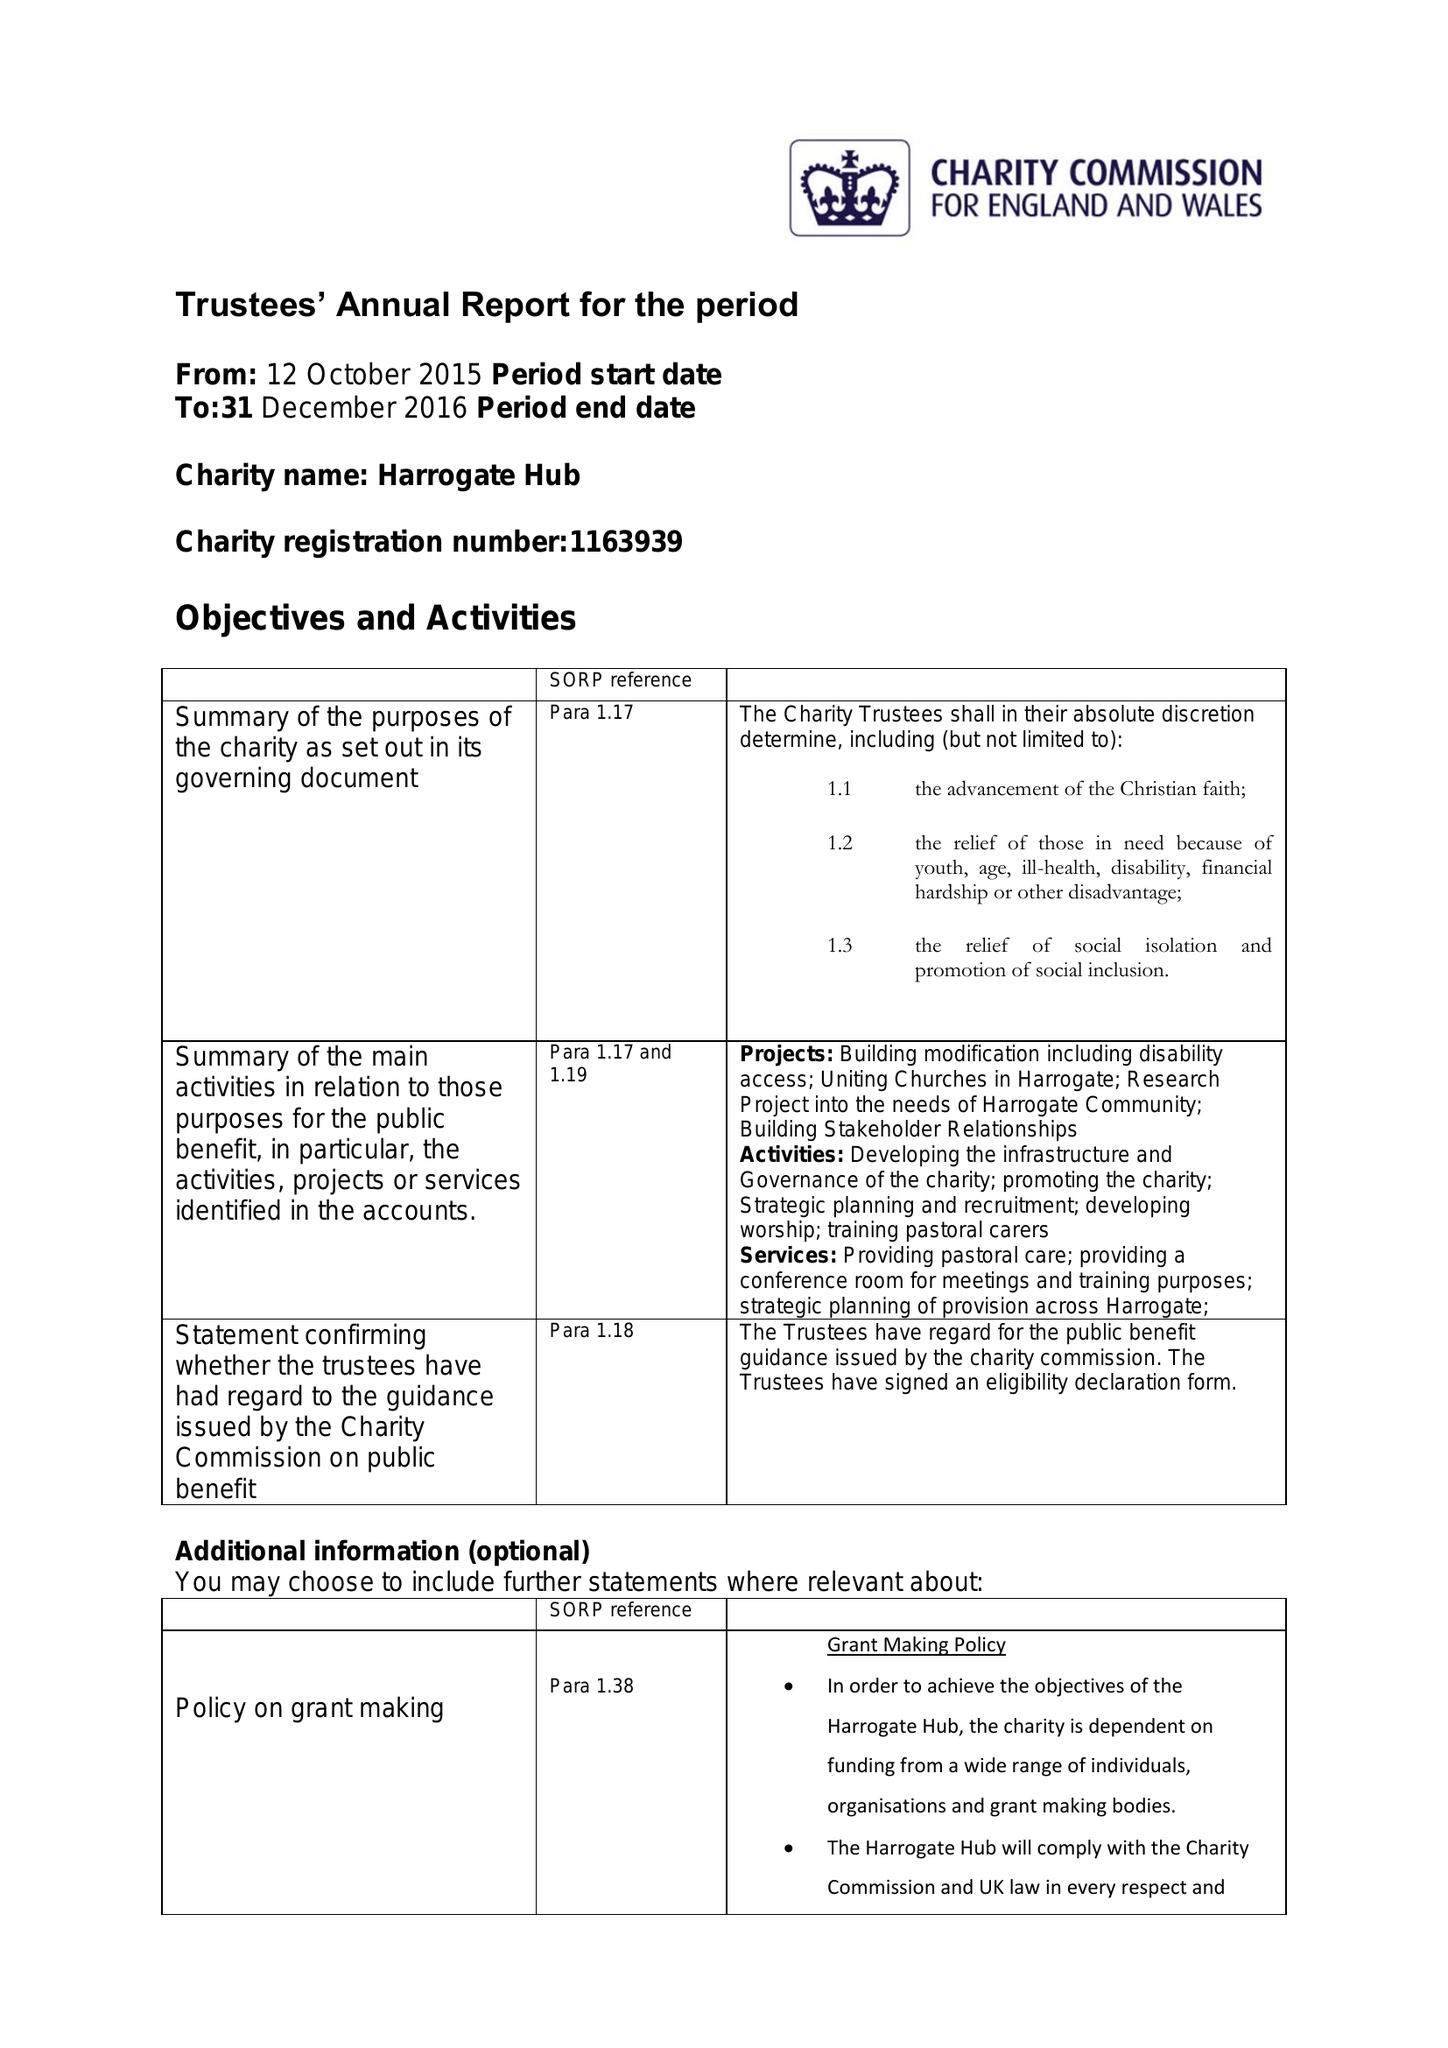What is the value for the address__street_line?
Answer the question using a single word or phrase. 39 OXFORD STREET 